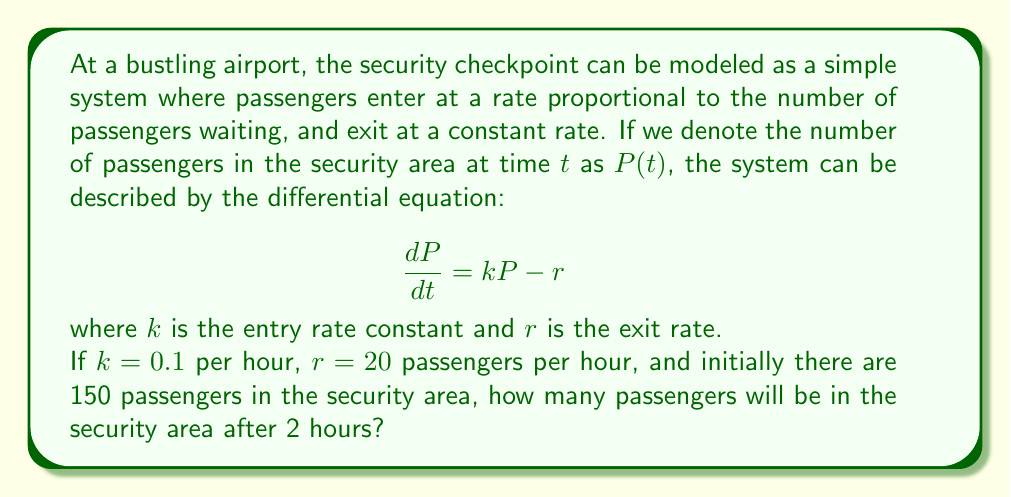Help me with this question. Let's solve this step-by-step:

1) We have the differential equation: $\frac{dP}{dt} = kP - r$

2) Given values:
   $k = 0.1$ per hour
   $r = 20$ passengers per hour
   $P(0) = 150$ passengers (initial condition)
   We need to find $P(2)$

3) This is a linear first-order differential equation. The general solution is:

   $$P(t) = \frac{r}{k} + Ce^{kt}$$

   where $C$ is a constant we need to determine.

4) Using the initial condition $P(0) = 150$:

   $$150 = \frac{20}{0.1} + C$$
   $$150 = 200 + C$$
   $$C = -50$$

5) So our particular solution is:

   $$P(t) = 200 - 50e^{0.1t}$$

6) Now we can find $P(2)$:

   $$P(2) = 200 - 50e^{0.1(2)}$$
   $$P(2) = 200 - 50e^{0.2}$$
   $$P(2) = 200 - 50(1.2214)$$
   $$P(2) = 200 - 61.07$$
   $$P(2) = 138.93$$

7) Rounding to the nearest whole number (as we can't have fractional passengers):

   $$P(2) \approx 139$$
Answer: 139 passengers 